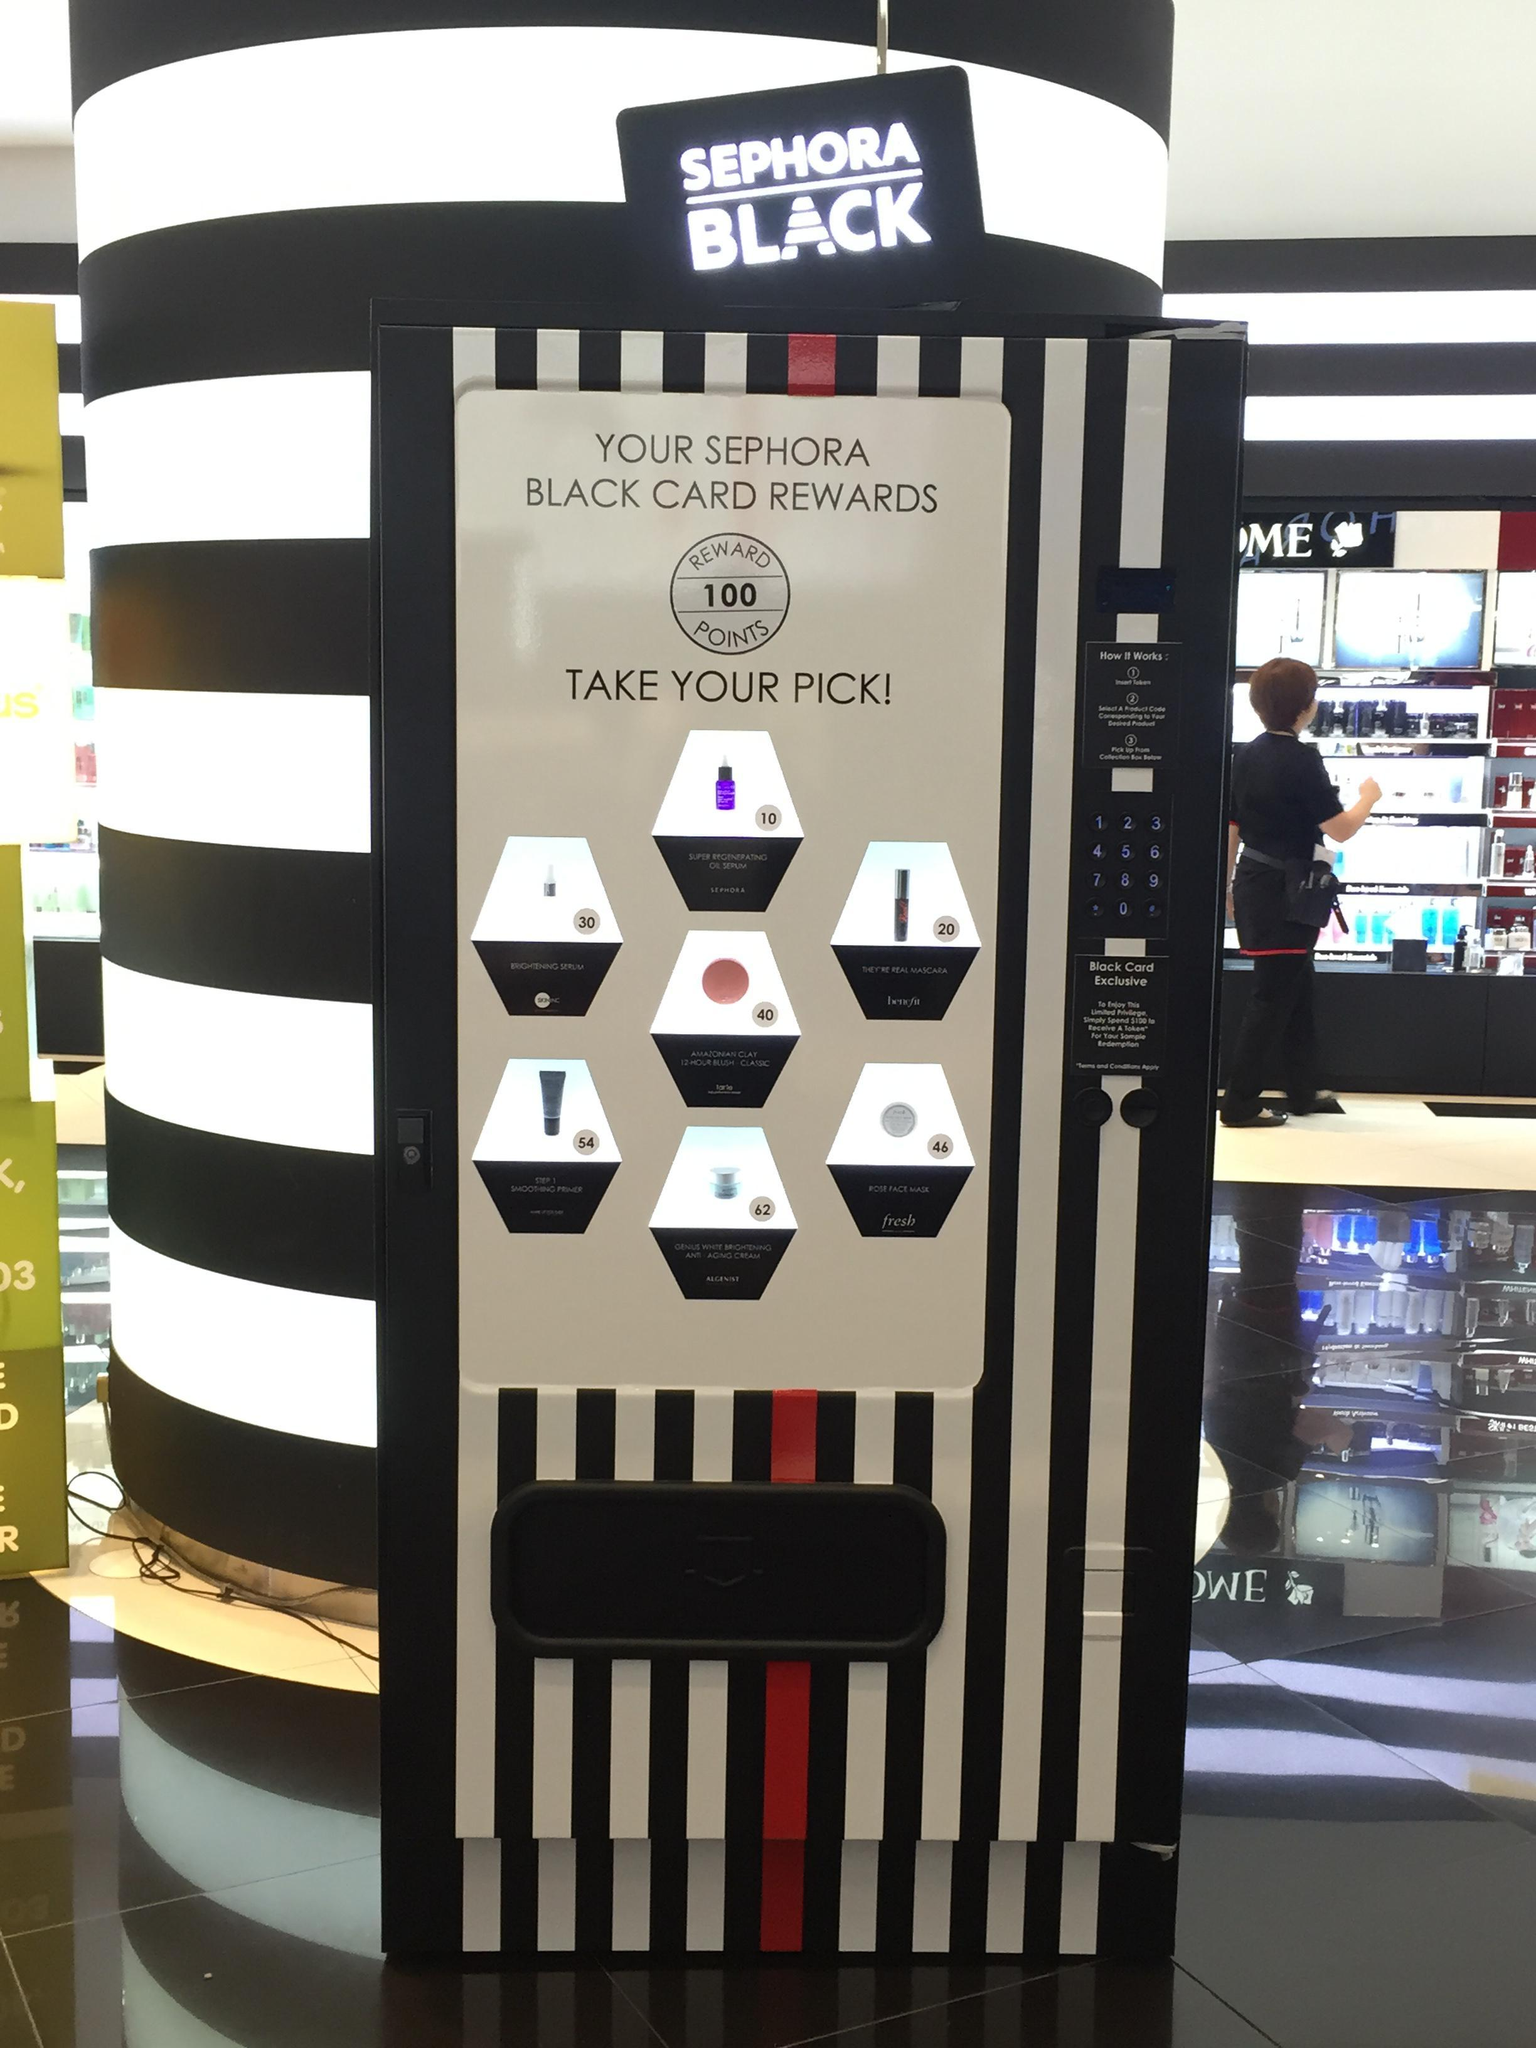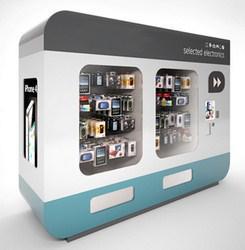The first image is the image on the left, the second image is the image on the right. Considering the images on both sides, is "Somewhere in one image, a back-turned person stands in front of a lit screen of some type." valid? Answer yes or no. Yes. 